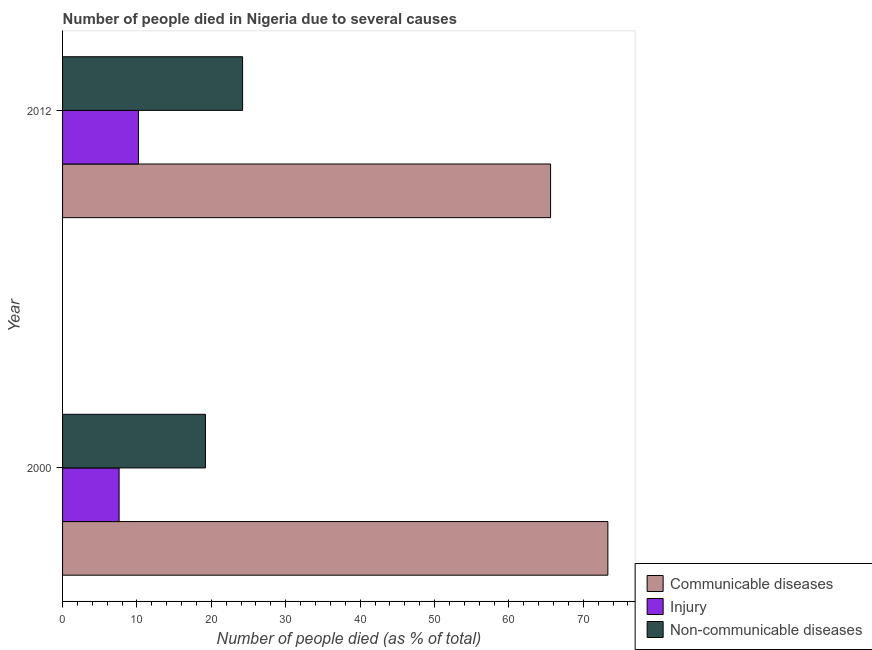How many different coloured bars are there?
Offer a very short reply. 3. How many bars are there on the 1st tick from the bottom?
Give a very brief answer. 3. What is the label of the 1st group of bars from the top?
Offer a terse response. 2012. What is the number of people who died of injury in 2000?
Keep it short and to the point. 7.6. Across all years, what is the maximum number of people who died of injury?
Make the answer very short. 10.2. Across all years, what is the minimum number of people who dies of non-communicable diseases?
Your answer should be very brief. 19.2. In which year was the number of people who died of injury maximum?
Keep it short and to the point. 2012. In which year was the number of people who died of communicable diseases minimum?
Make the answer very short. 2012. What is the total number of people who died of injury in the graph?
Give a very brief answer. 17.8. What is the difference between the number of people who died of communicable diseases in 2000 and the number of people who dies of non-communicable diseases in 2012?
Your answer should be very brief. 49.1. What is the average number of people who died of communicable diseases per year?
Your response must be concise. 69.45. In how many years, is the number of people who died of injury greater than 58 %?
Offer a very short reply. 0. What is the ratio of the number of people who dies of non-communicable diseases in 2000 to that in 2012?
Provide a succinct answer. 0.79. What does the 2nd bar from the top in 2000 represents?
Give a very brief answer. Injury. What does the 2nd bar from the bottom in 2000 represents?
Your answer should be very brief. Injury. How many years are there in the graph?
Offer a terse response. 2. What is the difference between two consecutive major ticks on the X-axis?
Ensure brevity in your answer.  10. Does the graph contain any zero values?
Your answer should be very brief. No. Where does the legend appear in the graph?
Ensure brevity in your answer.  Bottom right. How are the legend labels stacked?
Your answer should be compact. Vertical. What is the title of the graph?
Keep it short and to the point. Number of people died in Nigeria due to several causes. What is the label or title of the X-axis?
Your answer should be compact. Number of people died (as % of total). What is the Number of people died (as % of total) of Communicable diseases in 2000?
Offer a terse response. 73.3. What is the Number of people died (as % of total) in Communicable diseases in 2012?
Your answer should be very brief. 65.6. What is the Number of people died (as % of total) in Non-communicable diseases in 2012?
Your answer should be very brief. 24.2. Across all years, what is the maximum Number of people died (as % of total) of Communicable diseases?
Provide a short and direct response. 73.3. Across all years, what is the maximum Number of people died (as % of total) in Non-communicable diseases?
Ensure brevity in your answer.  24.2. Across all years, what is the minimum Number of people died (as % of total) of Communicable diseases?
Your answer should be compact. 65.6. Across all years, what is the minimum Number of people died (as % of total) in Injury?
Give a very brief answer. 7.6. Across all years, what is the minimum Number of people died (as % of total) in Non-communicable diseases?
Your answer should be compact. 19.2. What is the total Number of people died (as % of total) of Communicable diseases in the graph?
Your answer should be compact. 138.9. What is the total Number of people died (as % of total) in Injury in the graph?
Provide a short and direct response. 17.8. What is the total Number of people died (as % of total) in Non-communicable diseases in the graph?
Give a very brief answer. 43.4. What is the difference between the Number of people died (as % of total) of Communicable diseases in 2000 and that in 2012?
Your answer should be compact. 7.7. What is the difference between the Number of people died (as % of total) in Injury in 2000 and that in 2012?
Ensure brevity in your answer.  -2.6. What is the difference between the Number of people died (as % of total) of Non-communicable diseases in 2000 and that in 2012?
Your answer should be very brief. -5. What is the difference between the Number of people died (as % of total) in Communicable diseases in 2000 and the Number of people died (as % of total) in Injury in 2012?
Provide a succinct answer. 63.1. What is the difference between the Number of people died (as % of total) of Communicable diseases in 2000 and the Number of people died (as % of total) of Non-communicable diseases in 2012?
Your answer should be very brief. 49.1. What is the difference between the Number of people died (as % of total) of Injury in 2000 and the Number of people died (as % of total) of Non-communicable diseases in 2012?
Offer a very short reply. -16.6. What is the average Number of people died (as % of total) in Communicable diseases per year?
Your answer should be very brief. 69.45. What is the average Number of people died (as % of total) of Injury per year?
Offer a terse response. 8.9. What is the average Number of people died (as % of total) of Non-communicable diseases per year?
Your answer should be compact. 21.7. In the year 2000, what is the difference between the Number of people died (as % of total) of Communicable diseases and Number of people died (as % of total) of Injury?
Give a very brief answer. 65.7. In the year 2000, what is the difference between the Number of people died (as % of total) of Communicable diseases and Number of people died (as % of total) of Non-communicable diseases?
Your answer should be very brief. 54.1. In the year 2000, what is the difference between the Number of people died (as % of total) in Injury and Number of people died (as % of total) in Non-communicable diseases?
Ensure brevity in your answer.  -11.6. In the year 2012, what is the difference between the Number of people died (as % of total) in Communicable diseases and Number of people died (as % of total) in Injury?
Ensure brevity in your answer.  55.4. In the year 2012, what is the difference between the Number of people died (as % of total) of Communicable diseases and Number of people died (as % of total) of Non-communicable diseases?
Provide a short and direct response. 41.4. In the year 2012, what is the difference between the Number of people died (as % of total) in Injury and Number of people died (as % of total) in Non-communicable diseases?
Your answer should be compact. -14. What is the ratio of the Number of people died (as % of total) of Communicable diseases in 2000 to that in 2012?
Keep it short and to the point. 1.12. What is the ratio of the Number of people died (as % of total) in Injury in 2000 to that in 2012?
Your answer should be compact. 0.75. What is the ratio of the Number of people died (as % of total) of Non-communicable diseases in 2000 to that in 2012?
Provide a succinct answer. 0.79. What is the difference between the highest and the second highest Number of people died (as % of total) in Non-communicable diseases?
Provide a succinct answer. 5. What is the difference between the highest and the lowest Number of people died (as % of total) in Communicable diseases?
Your answer should be compact. 7.7. What is the difference between the highest and the lowest Number of people died (as % of total) of Injury?
Offer a very short reply. 2.6. 